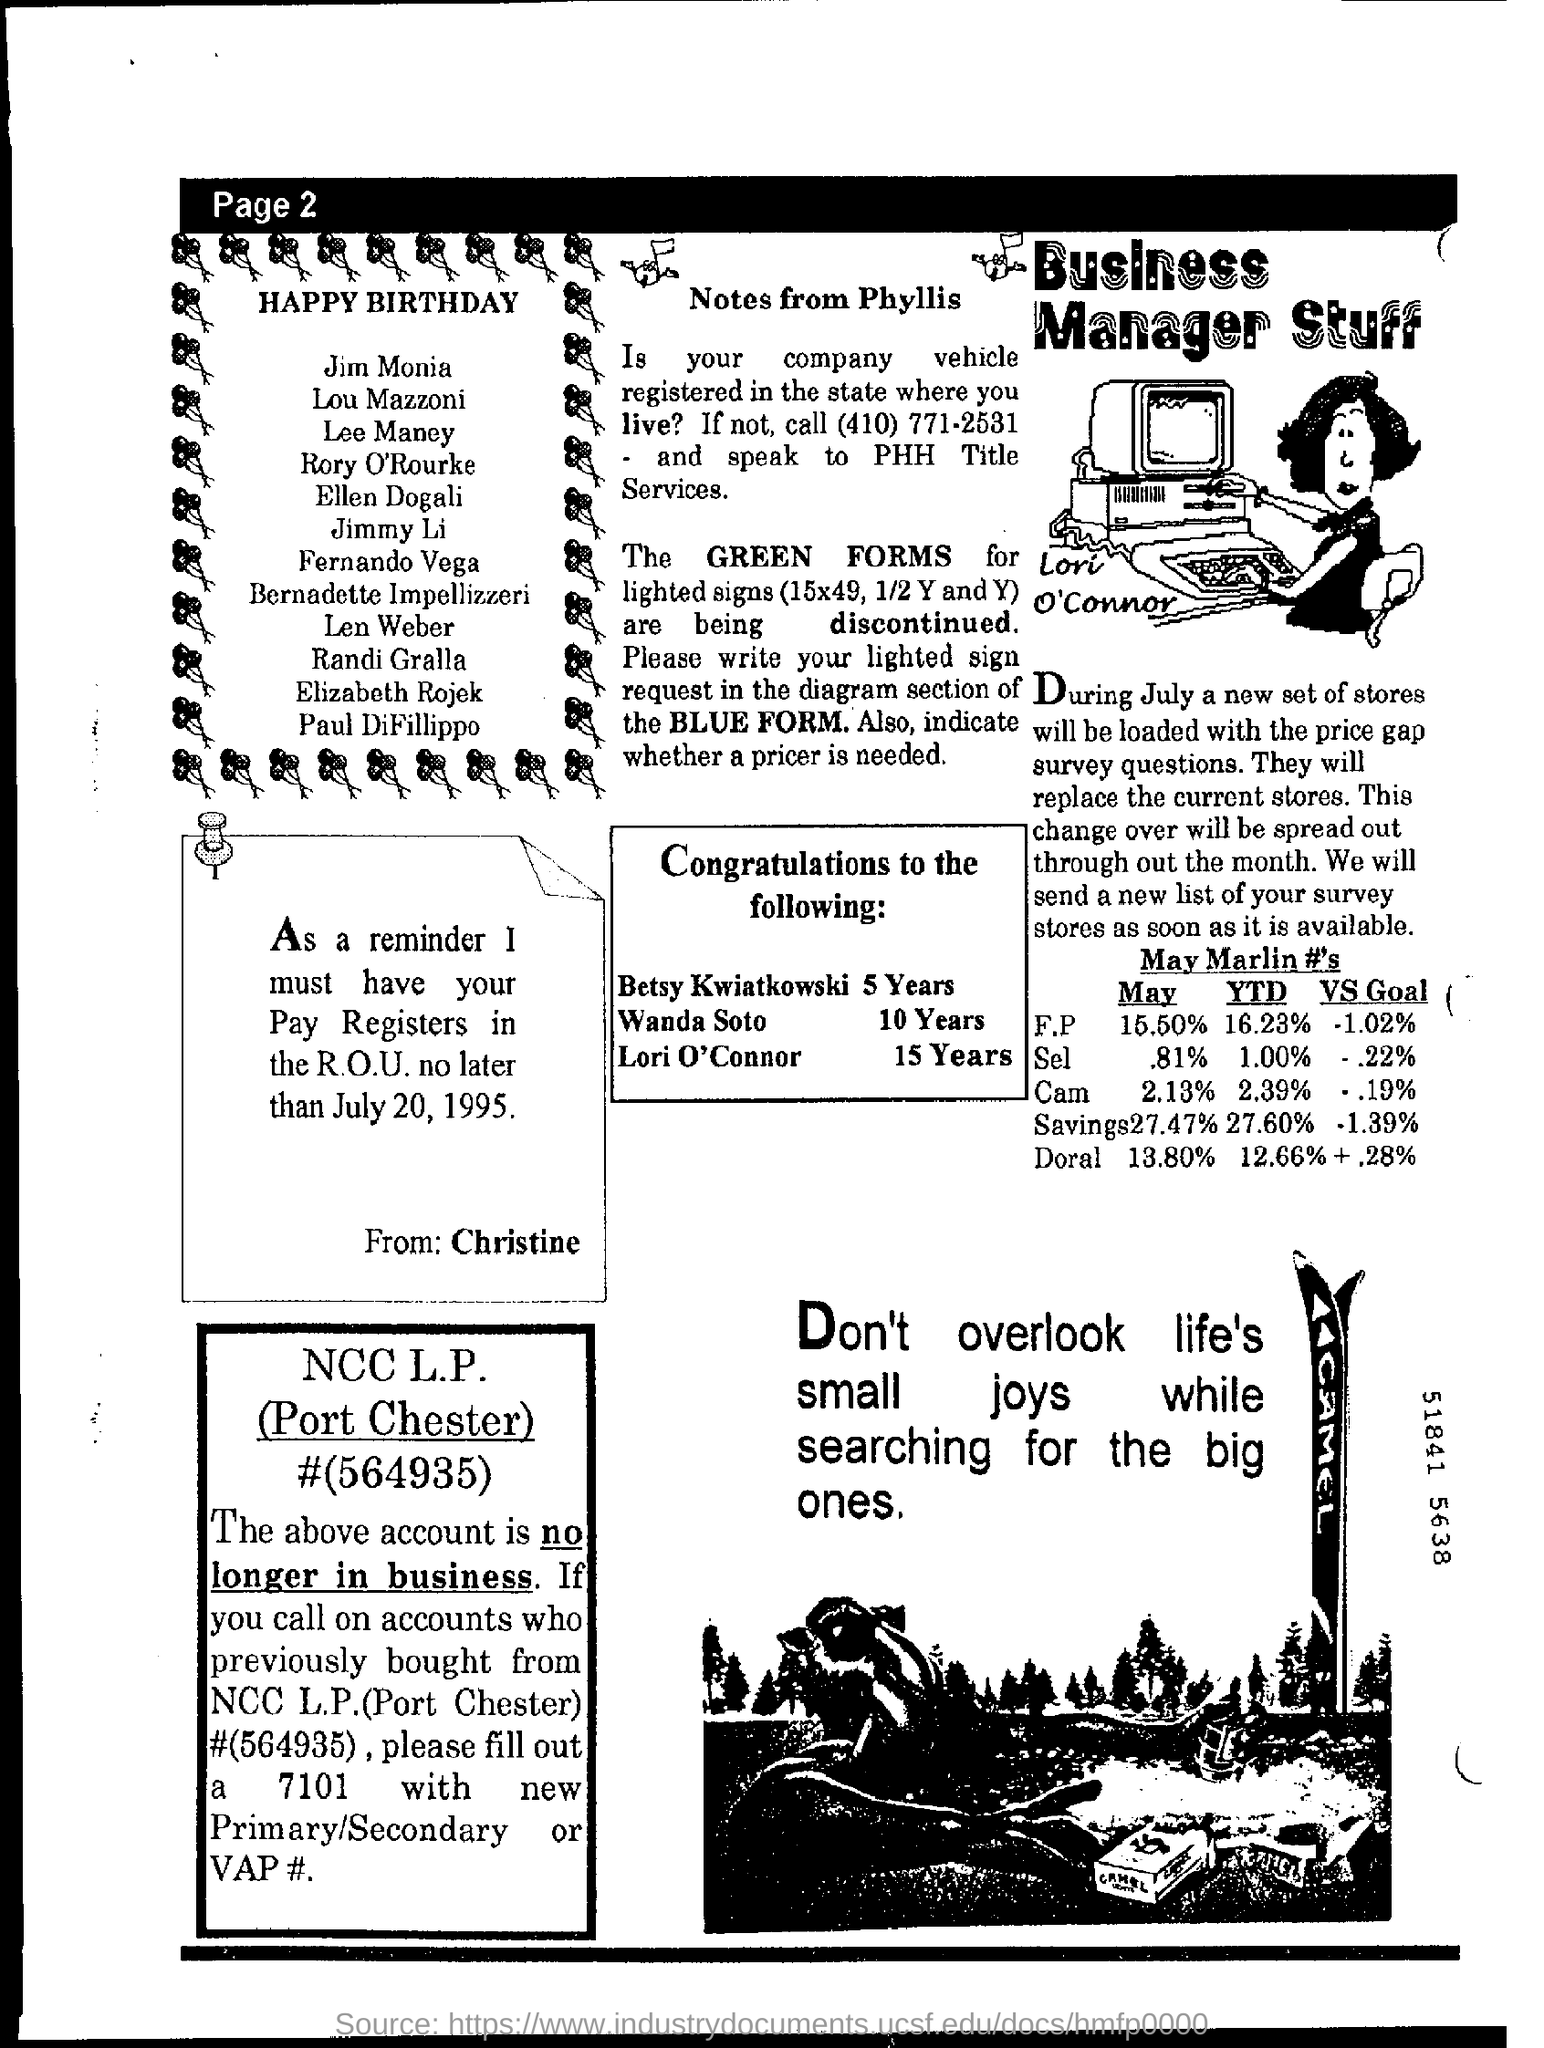Outline some significant characteristics in this image. It is imperative that Christine receives the payroll registers in the Rockwell Operations Unit no later than July 20, 1995. 